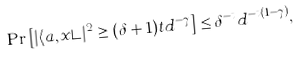Convert formula to latex. <formula><loc_0><loc_0><loc_500><loc_500>\Pr \left [ | \langle a , x \rangle | ^ { 2 } \geq ( \delta + 1 ) t d ^ { - \gamma } \right ] \leq \delta ^ { - t } d ^ { - t ( 1 - \gamma ) } ,</formula> 